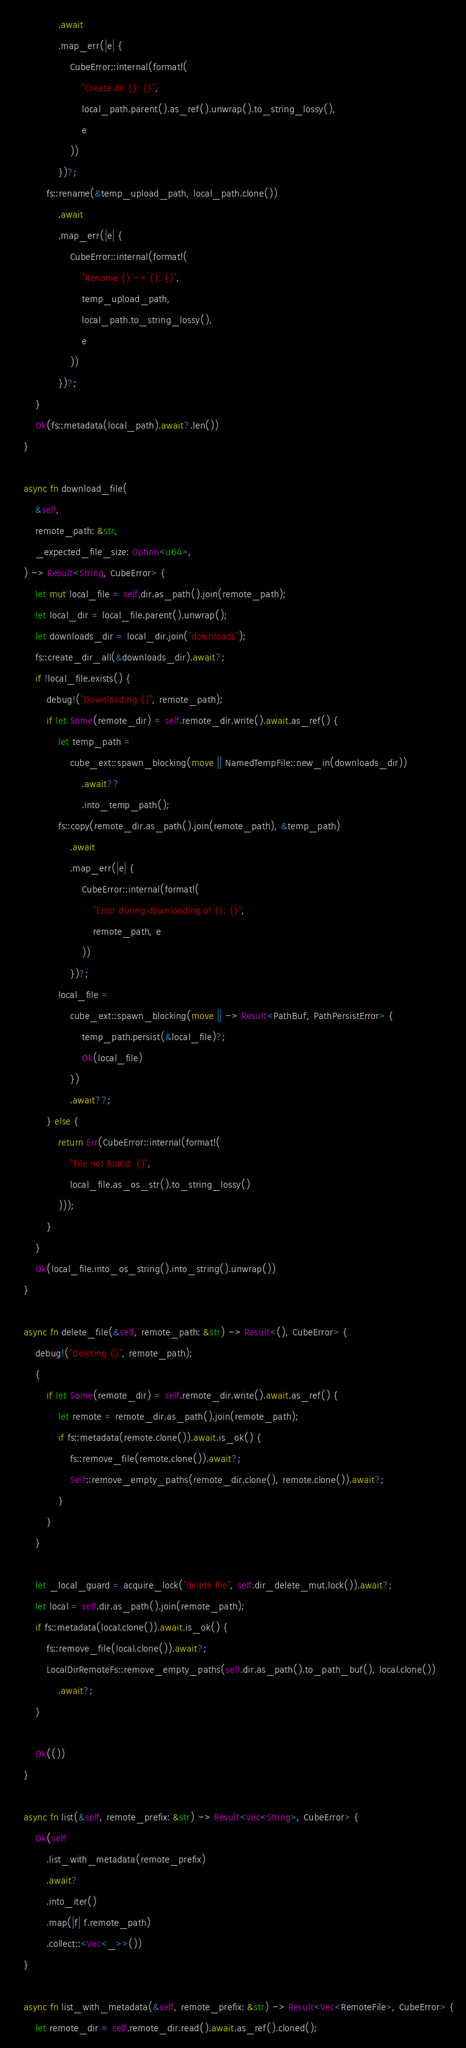Convert code to text. <code><loc_0><loc_0><loc_500><loc_500><_Rust_>                .await
                .map_err(|e| {
                    CubeError::internal(format!(
                        "Create dir {}: {}",
                        local_path.parent().as_ref().unwrap().to_string_lossy(),
                        e
                    ))
                })?;
            fs::rename(&temp_upload_path, local_path.clone())
                .await
                .map_err(|e| {
                    CubeError::internal(format!(
                        "Rename {} -> {}: {}",
                        temp_upload_path,
                        local_path.to_string_lossy(),
                        e
                    ))
                })?;
        }
        Ok(fs::metadata(local_path).await?.len())
    }

    async fn download_file(
        &self,
        remote_path: &str,
        _expected_file_size: Option<u64>,
    ) -> Result<String, CubeError> {
        let mut local_file = self.dir.as_path().join(remote_path);
        let local_dir = local_file.parent().unwrap();
        let downloads_dir = local_dir.join("downloads");
        fs::create_dir_all(&downloads_dir).await?;
        if !local_file.exists() {
            debug!("Downloading {}", remote_path);
            if let Some(remote_dir) = self.remote_dir.write().await.as_ref() {
                let temp_path =
                    cube_ext::spawn_blocking(move || NamedTempFile::new_in(downloads_dir))
                        .await??
                        .into_temp_path();
                fs::copy(remote_dir.as_path().join(remote_path), &temp_path)
                    .await
                    .map_err(|e| {
                        CubeError::internal(format!(
                            "Error during downloading of {}: {}",
                            remote_path, e
                        ))
                    })?;
                local_file =
                    cube_ext::spawn_blocking(move || -> Result<PathBuf, PathPersistError> {
                        temp_path.persist(&local_file)?;
                        Ok(local_file)
                    })
                    .await??;
            } else {
                return Err(CubeError::internal(format!(
                    "File not found: {}",
                    local_file.as_os_str().to_string_lossy()
                )));
            }
        }
        Ok(local_file.into_os_string().into_string().unwrap())
    }

    async fn delete_file(&self, remote_path: &str) -> Result<(), CubeError> {
        debug!("Deleting {}", remote_path);
        {
            if let Some(remote_dir) = self.remote_dir.write().await.as_ref() {
                let remote = remote_dir.as_path().join(remote_path);
                if fs::metadata(remote.clone()).await.is_ok() {
                    fs::remove_file(remote.clone()).await?;
                    Self::remove_empty_paths(remote_dir.clone(), remote.clone()).await?;
                }
            }
        }

        let _local_guard = acquire_lock("delete file", self.dir_delete_mut.lock()).await?;
        let local = self.dir.as_path().join(remote_path);
        if fs::metadata(local.clone()).await.is_ok() {
            fs::remove_file(local.clone()).await?;
            LocalDirRemoteFs::remove_empty_paths(self.dir.as_path().to_path_buf(), local.clone())
                .await?;
        }

        Ok(())
    }

    async fn list(&self, remote_prefix: &str) -> Result<Vec<String>, CubeError> {
        Ok(self
            .list_with_metadata(remote_prefix)
            .await?
            .into_iter()
            .map(|f| f.remote_path)
            .collect::<Vec<_>>())
    }

    async fn list_with_metadata(&self, remote_prefix: &str) -> Result<Vec<RemoteFile>, CubeError> {
        let remote_dir = self.remote_dir.read().await.as_ref().cloned();</code> 